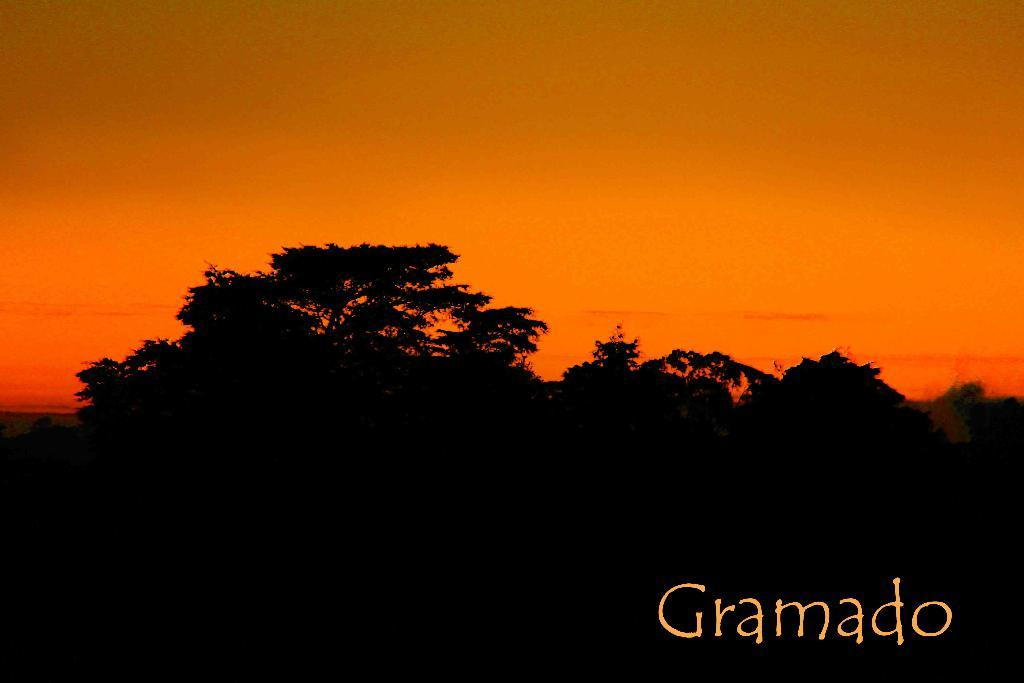What is the general appearance of the bottom part of the image? There is a dark view at the bottom of the image. What type of natural elements can be seen in the image? There are trees visible in the image. Are there any words or letters in the image? Yes, there is text visible in the image. What color stands out in the middle of the image? There is orange color in the middle of the image. What type of flag is flying on the dock in the image? There is no flag or dock present in the image; it features a dark view, trees, text, and orange color. Can you describe the orange creature that is visible in the image? There is no creature, orange or otherwise, visible in the image. 